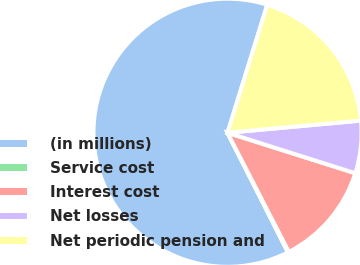<chart> <loc_0><loc_0><loc_500><loc_500><pie_chart><fcel>(in millions)<fcel>Service cost<fcel>Interest cost<fcel>Net losses<fcel>Net periodic pension and<nl><fcel>62.24%<fcel>0.12%<fcel>12.55%<fcel>6.33%<fcel>18.76%<nl></chart> 